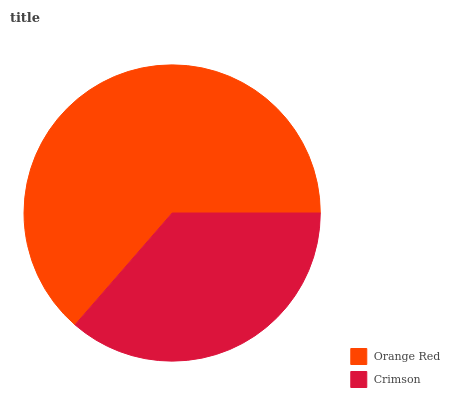Is Crimson the minimum?
Answer yes or no. Yes. Is Orange Red the maximum?
Answer yes or no. Yes. Is Crimson the maximum?
Answer yes or no. No. Is Orange Red greater than Crimson?
Answer yes or no. Yes. Is Crimson less than Orange Red?
Answer yes or no. Yes. Is Crimson greater than Orange Red?
Answer yes or no. No. Is Orange Red less than Crimson?
Answer yes or no. No. Is Orange Red the high median?
Answer yes or no. Yes. Is Crimson the low median?
Answer yes or no. Yes. Is Crimson the high median?
Answer yes or no. No. Is Orange Red the low median?
Answer yes or no. No. 